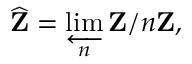<formula> <loc_0><loc_0><loc_500><loc_500>{ \widehat { Z } } = \varprojlim _ { n } Z / n Z ,</formula> 